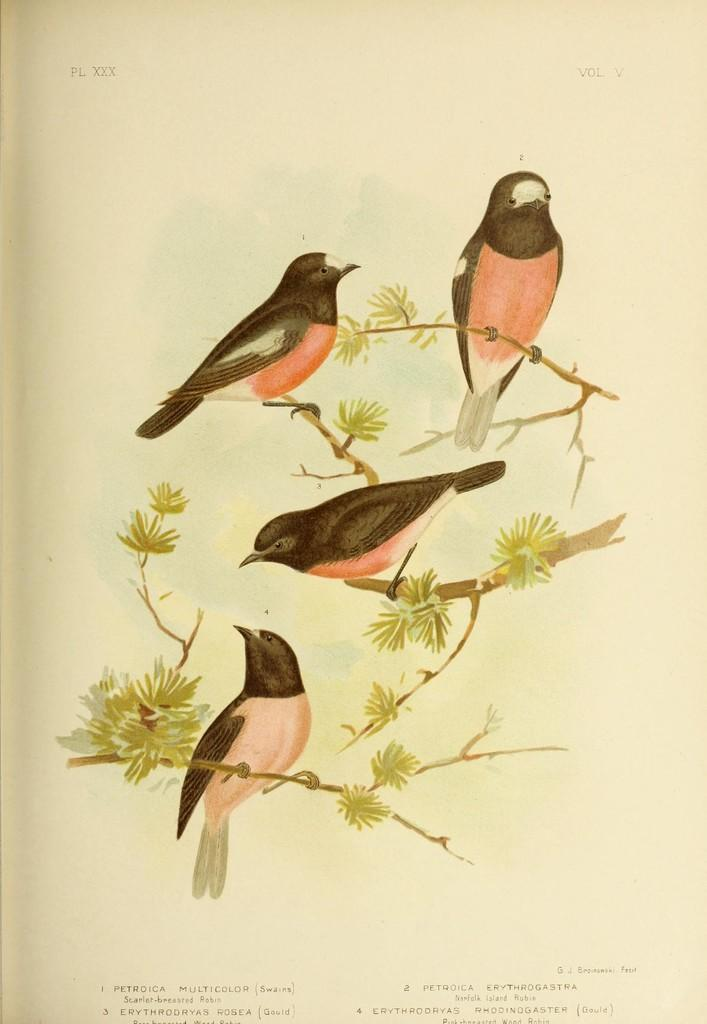What type of animals can be seen in the image? Birds can be seen in the image. Where are the birds located in the image? The birds are sitting on the branch of a tree. What force is causing the birds to attack in the image? There is no force causing the birds to attack in the image, as there is no indication of an attack or any aggressive behavior. 